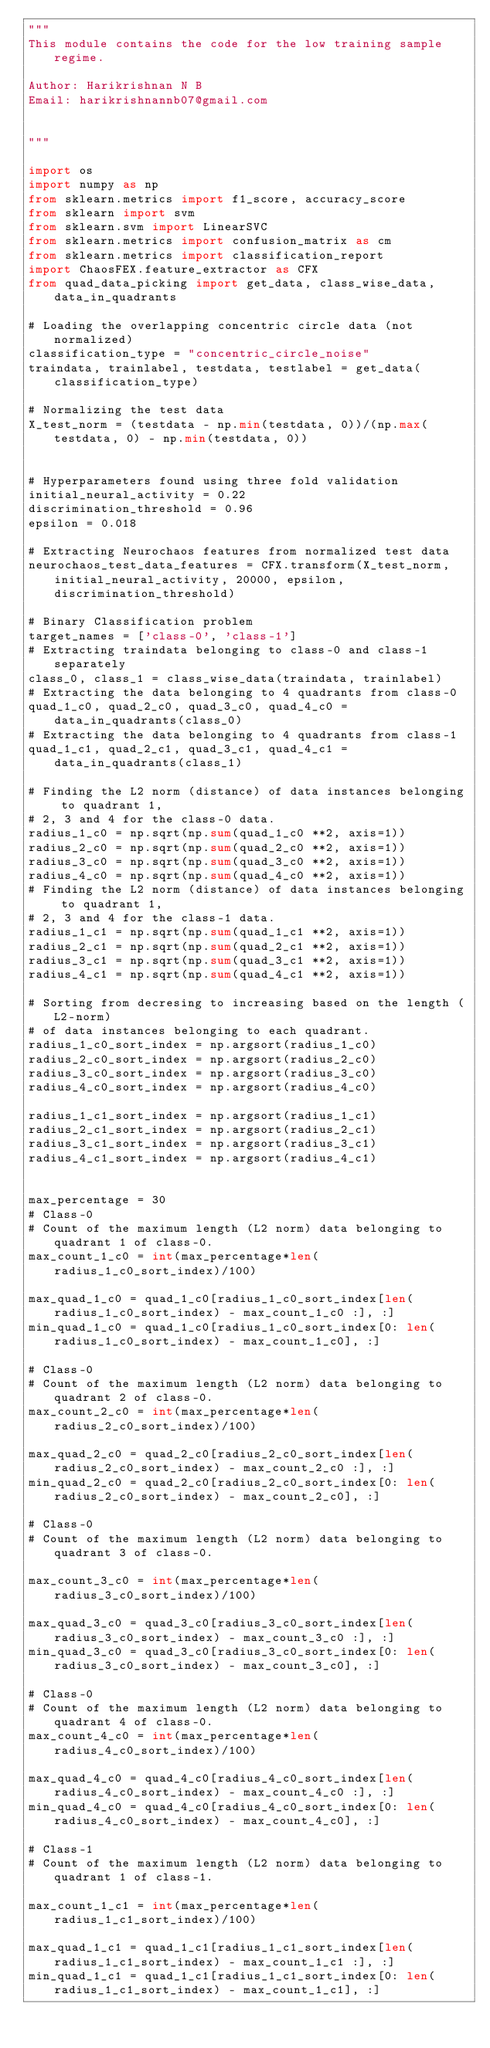Convert code to text. <code><loc_0><loc_0><loc_500><loc_500><_Python_>"""
This module contains the code for the low training sample regime.

Author: Harikrishnan N B
Email: harikrishnannb07@gmail.com


"""

import os
import numpy as np
from sklearn.metrics import f1_score, accuracy_score
from sklearn import svm
from sklearn.svm import LinearSVC
from sklearn.metrics import confusion_matrix as cm
from sklearn.metrics import classification_report
import ChaosFEX.feature_extractor as CFX
from quad_data_picking import get_data, class_wise_data, data_in_quadrants

# Loading the overlapping concentric circle data (not normalized)
classification_type = "concentric_circle_noise"
traindata, trainlabel, testdata, testlabel = get_data(classification_type)

# Normalizing the test data
X_test_norm = (testdata - np.min(testdata, 0))/(np.max(testdata, 0) - np.min(testdata, 0))


# Hyperparameters found using three fold validation
initial_neural_activity = 0.22
discrimination_threshold = 0.96
epsilon = 0.018

# Extracting Neurochaos features from normalized test data
neurochaos_test_data_features = CFX.transform(X_test_norm, initial_neural_activity, 20000, epsilon, discrimination_threshold)

# Binary Classification problem
target_names = ['class-0', 'class-1']
# Extracting traindata belonging to class-0 and class-1 separately
class_0, class_1 = class_wise_data(traindata, trainlabel)
# Extracting the data belonging to 4 quadrants from class-0
quad_1_c0, quad_2_c0, quad_3_c0, quad_4_c0 = data_in_quadrants(class_0)
# Extracting the data belonging to 4 quadrants from class-1
quad_1_c1, quad_2_c1, quad_3_c1, quad_4_c1 = data_in_quadrants(class_1)

# Finding the L2 norm (distance) of data instances belonging to quadrant 1,
# 2, 3 and 4 for the class-0 data.
radius_1_c0 = np.sqrt(np.sum(quad_1_c0 **2, axis=1))
radius_2_c0 = np.sqrt(np.sum(quad_2_c0 **2, axis=1))
radius_3_c0 = np.sqrt(np.sum(quad_3_c0 **2, axis=1))
radius_4_c0 = np.sqrt(np.sum(quad_4_c0 **2, axis=1))
# Finding the L2 norm (distance) of data instances belonging to quadrant 1,
# 2, 3 and 4 for the class-1 data.
radius_1_c1 = np.sqrt(np.sum(quad_1_c1 **2, axis=1))
radius_2_c1 = np.sqrt(np.sum(quad_2_c1 **2, axis=1))
radius_3_c1 = np.sqrt(np.sum(quad_3_c1 **2, axis=1))
radius_4_c1 = np.sqrt(np.sum(quad_4_c1 **2, axis=1))

# Sorting from decresing to increasing based on the length (L2-norm)
# of data instances belonging to each quadrant.
radius_1_c0_sort_index = np.argsort(radius_1_c0)
radius_2_c0_sort_index = np.argsort(radius_2_c0)
radius_3_c0_sort_index = np.argsort(radius_3_c0)
radius_4_c0_sort_index = np.argsort(radius_4_c0)

radius_1_c1_sort_index = np.argsort(radius_1_c1)
radius_2_c1_sort_index = np.argsort(radius_2_c1)
radius_3_c1_sort_index = np.argsort(radius_3_c1)
radius_4_c1_sort_index = np.argsort(radius_4_c1)


max_percentage = 30
# Class-0
# Count of the maximum length (L2 norm) data belonging to quadrant 1 of class-0.
max_count_1_c0 = int(max_percentage*len(radius_1_c0_sort_index)/100)

max_quad_1_c0 = quad_1_c0[radius_1_c0_sort_index[len(radius_1_c0_sort_index) - max_count_1_c0 :], :]
min_quad_1_c0 = quad_1_c0[radius_1_c0_sort_index[0: len(radius_1_c0_sort_index) - max_count_1_c0], :]

# Class-0
# Count of the maximum length (L2 norm) data belonging to quadrant 2 of class-0.
max_count_2_c0 = int(max_percentage*len(radius_2_c0_sort_index)/100)

max_quad_2_c0 = quad_2_c0[radius_2_c0_sort_index[len(radius_2_c0_sort_index) - max_count_2_c0 :], :]
min_quad_2_c0 = quad_2_c0[radius_2_c0_sort_index[0: len(radius_2_c0_sort_index) - max_count_2_c0], :]

# Class-0
# Count of the maximum length (L2 norm) data belonging to quadrant 3 of class-0.

max_count_3_c0 = int(max_percentage*len(radius_3_c0_sort_index)/100)

max_quad_3_c0 = quad_3_c0[radius_3_c0_sort_index[len(radius_3_c0_sort_index) - max_count_3_c0 :], :]
min_quad_3_c0 = quad_3_c0[radius_3_c0_sort_index[0: len(radius_3_c0_sort_index) - max_count_3_c0], :]

# Class-0
# Count of the maximum length (L2 norm) data belonging to quadrant 4 of class-0.
max_count_4_c0 = int(max_percentage*len(radius_4_c0_sort_index)/100)

max_quad_4_c0 = quad_4_c0[radius_4_c0_sort_index[len(radius_4_c0_sort_index) - max_count_4_c0 :], :]
min_quad_4_c0 = quad_4_c0[radius_4_c0_sort_index[0: len(radius_4_c0_sort_index) - max_count_4_c0], :]

# Class-1
# Count of the maximum length (L2 norm) data belonging to quadrant 1 of class-1.

max_count_1_c1 = int(max_percentage*len(radius_1_c1_sort_index)/100)

max_quad_1_c1 = quad_1_c1[radius_1_c1_sort_index[len(radius_1_c1_sort_index) - max_count_1_c1 :], :]
min_quad_1_c1 = quad_1_c1[radius_1_c1_sort_index[0: len(radius_1_c1_sort_index) - max_count_1_c1], :]
</code> 